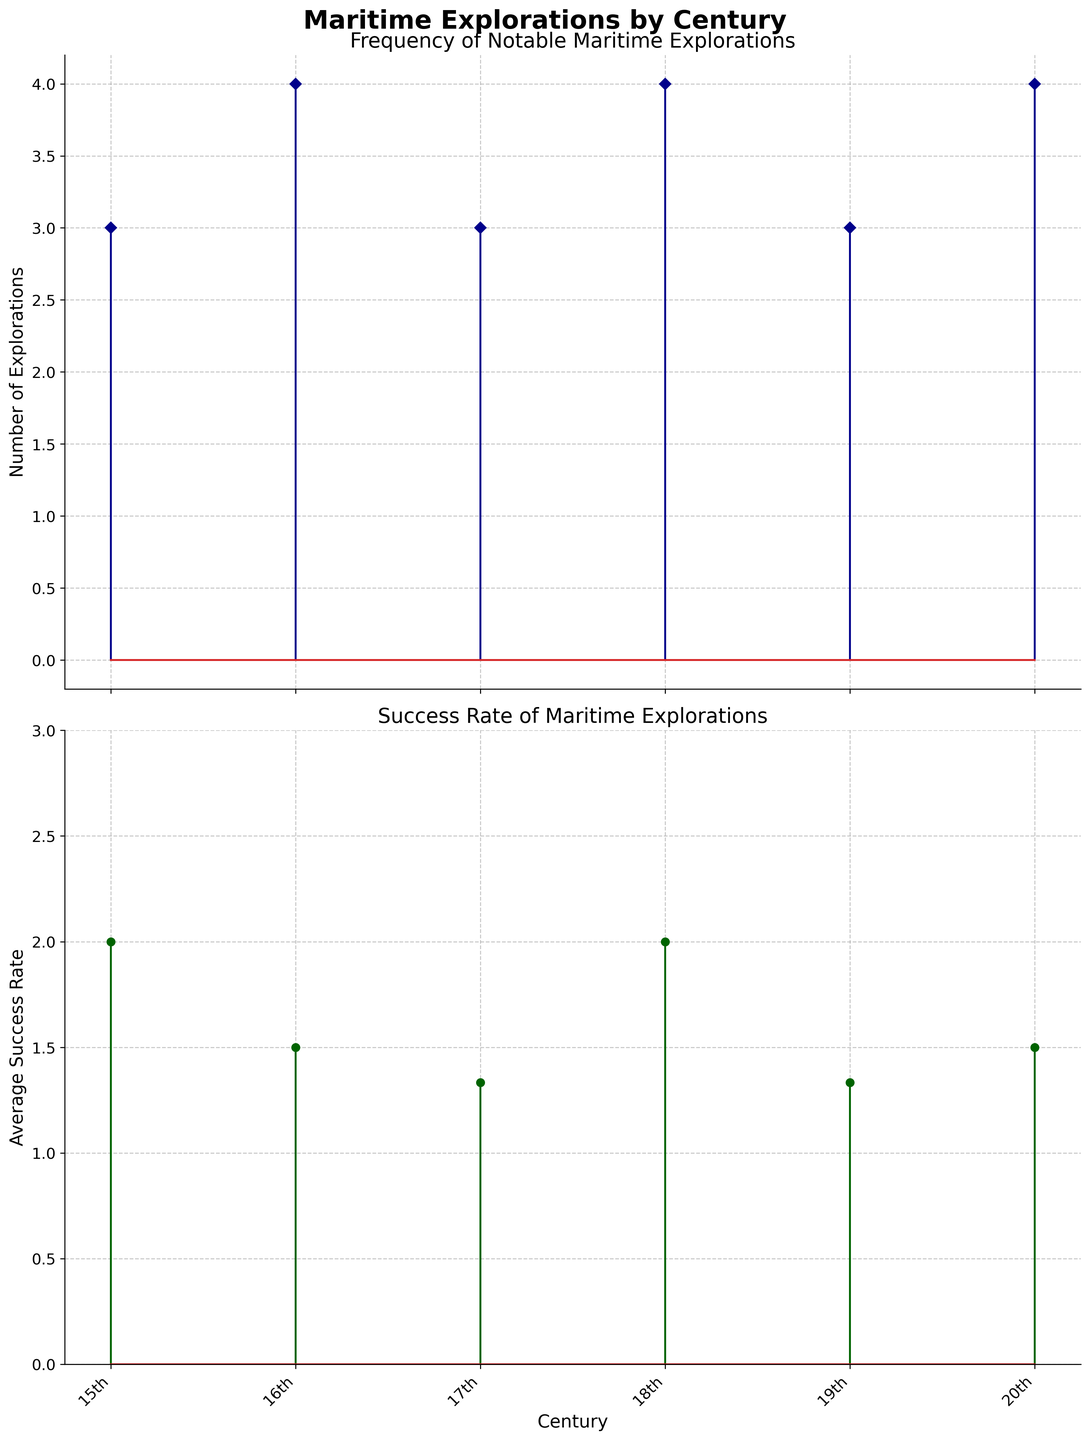What is the title of the figure? The title of the figure is located at the top of the plot and provides an overview of the content.
Answer: Maritime Explorations by Century How many notable maritime explorations were there in the 15th century? The number of notable maritime explorations for each century is shown on the first subplot, where stem lines indicate the frequency. By counting the points on the line corresponding to the 15th century, we determine the total.
Answer: 3 Which century had the highest average success rate of maritime explorations? To find the highest average success rate, look at the second subplot and compare the heights of the points. The century with the tallest point has the highest success rate.
Answer: 18th century What was the average success rate of maritime explorations in the 19th century? The second subplot shows the average success rates with stem lines and markers. Identify the height of the marker for the 19th century and read the corresponding value from the y-axis.
Answer: 1.5 How does the frequency of explorations in the 16th century compare to the 18th century? Compare the height of the stem lines in the first subplot for the 16th and 18th centuries. The frequency is represented by the vertical position of the markers.
Answer: Same (both have 4 explorations) What is the minimum success rate observed across all centuries? To find the minimum success rate, check the second subplot for the lowest point, and read its value from the y-axis.
Answer: 0 How did the notable maritime explorations in the 17th century fare in terms of success rate compared to those in the 20th century? Observe the second subplot to compare the average success rates of the 17th and 20th centuries by comparing the heights of their markers.
Answer: 17th century has a lower average success rate (17th: 1, 20th: 1.5) Which century saw the most notable explorations? Determine the century with the highest markers in the first subplot by comparing their heights.
Answer: 18th century Is there a century where the average success rate is exactly 2? Check the second subplot for a century whose marker's height intersects the y-axis at 2.
Answer: Yes, the 20th century What is the difference in the number of explorations between the 15th and 17th centuries? Subtract the number of explorations in the 15th century from the number in the 17th century using the data in the first subplot.
Answer: -1 